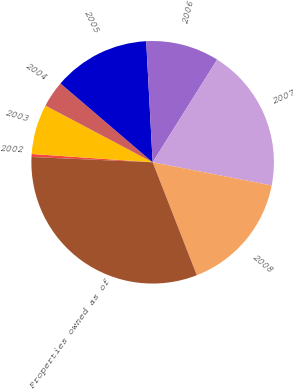<chart> <loc_0><loc_0><loc_500><loc_500><pie_chart><fcel>2002<fcel>2003<fcel>2004<fcel>2005<fcel>2006<fcel>2007<fcel>2008<fcel>Properties owned as of<nl><fcel>0.4%<fcel>6.65%<fcel>3.52%<fcel>12.89%<fcel>9.77%<fcel>19.14%<fcel>16.01%<fcel>31.63%<nl></chart> 